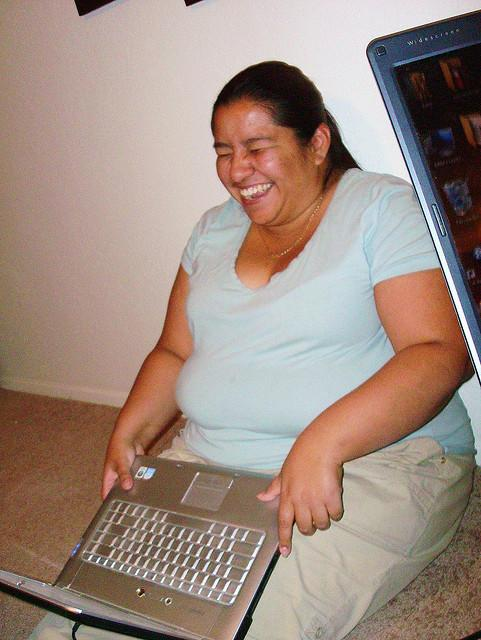What OS is the laptop on the right displaying on its screen? Please explain your reasoning. windows vista. The laptop says windows 10 on top of the screen. 